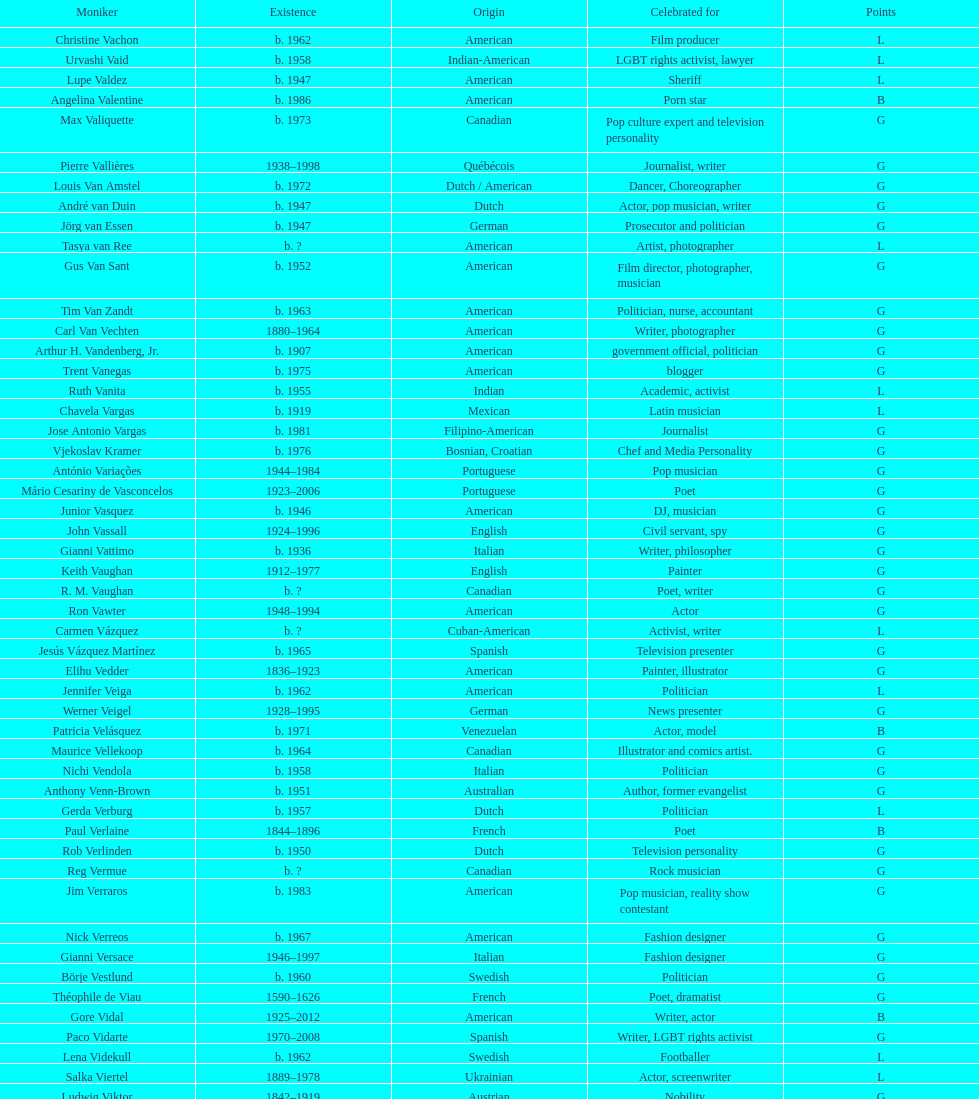What is the number of individuals in this group who were indian? 1. 